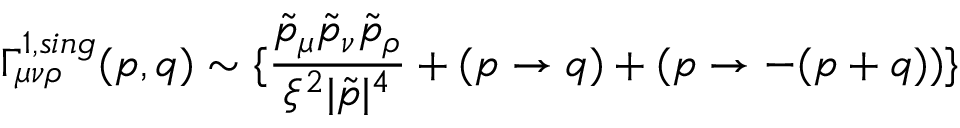<formula> <loc_0><loc_0><loc_500><loc_500>\Gamma _ { \mu \nu \rho } ^ { 1 , \sin g } ( p , q ) \sim \{ \frac { \tilde { p } _ { \mu } \tilde { p } _ { \nu } \tilde { p } _ { \rho } } { \xi ^ { 2 } | \tilde { p } | ^ { 4 } } + ( p \rightarrow q ) + ( p \rightarrow - ( p + q ) ) \}</formula> 